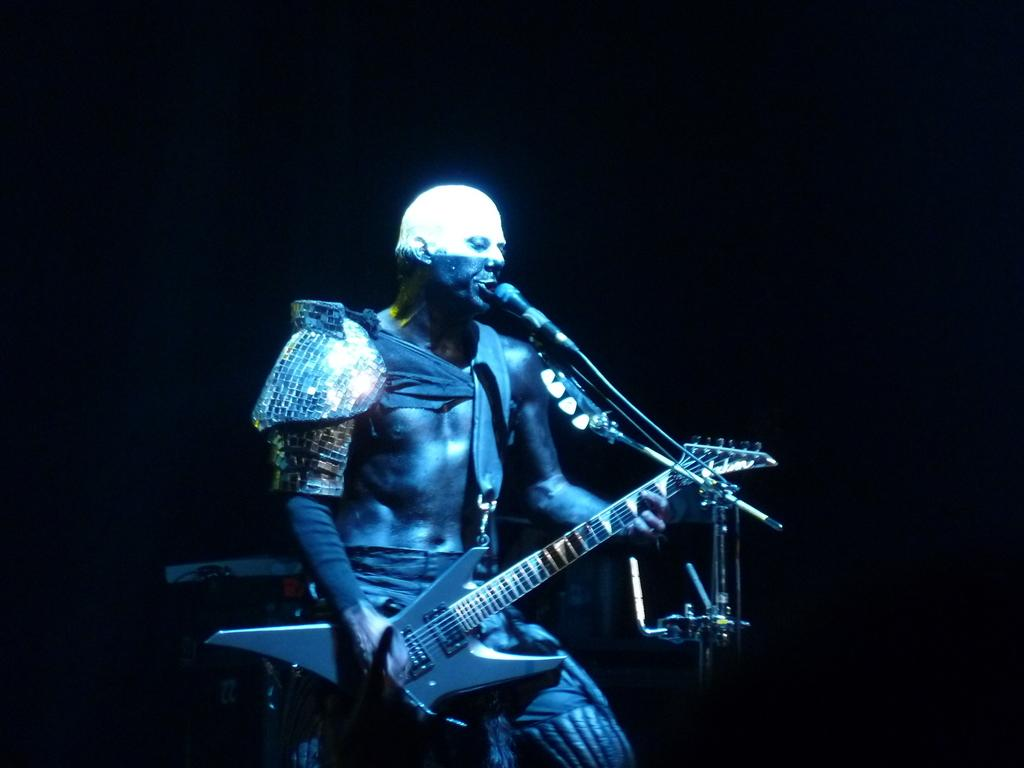Who is the main subject in the image? There is a man in the image. What is the man doing in the image? The man is playing a guitar and singing a song. What object is in front of the man? There is a microphone in front of the man. What color is the daughter's dress in the image? There is no daughter present in the image, so we cannot answer a question about her dress. 